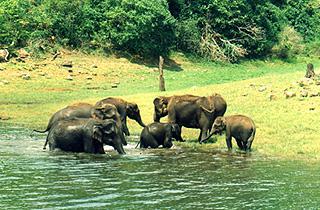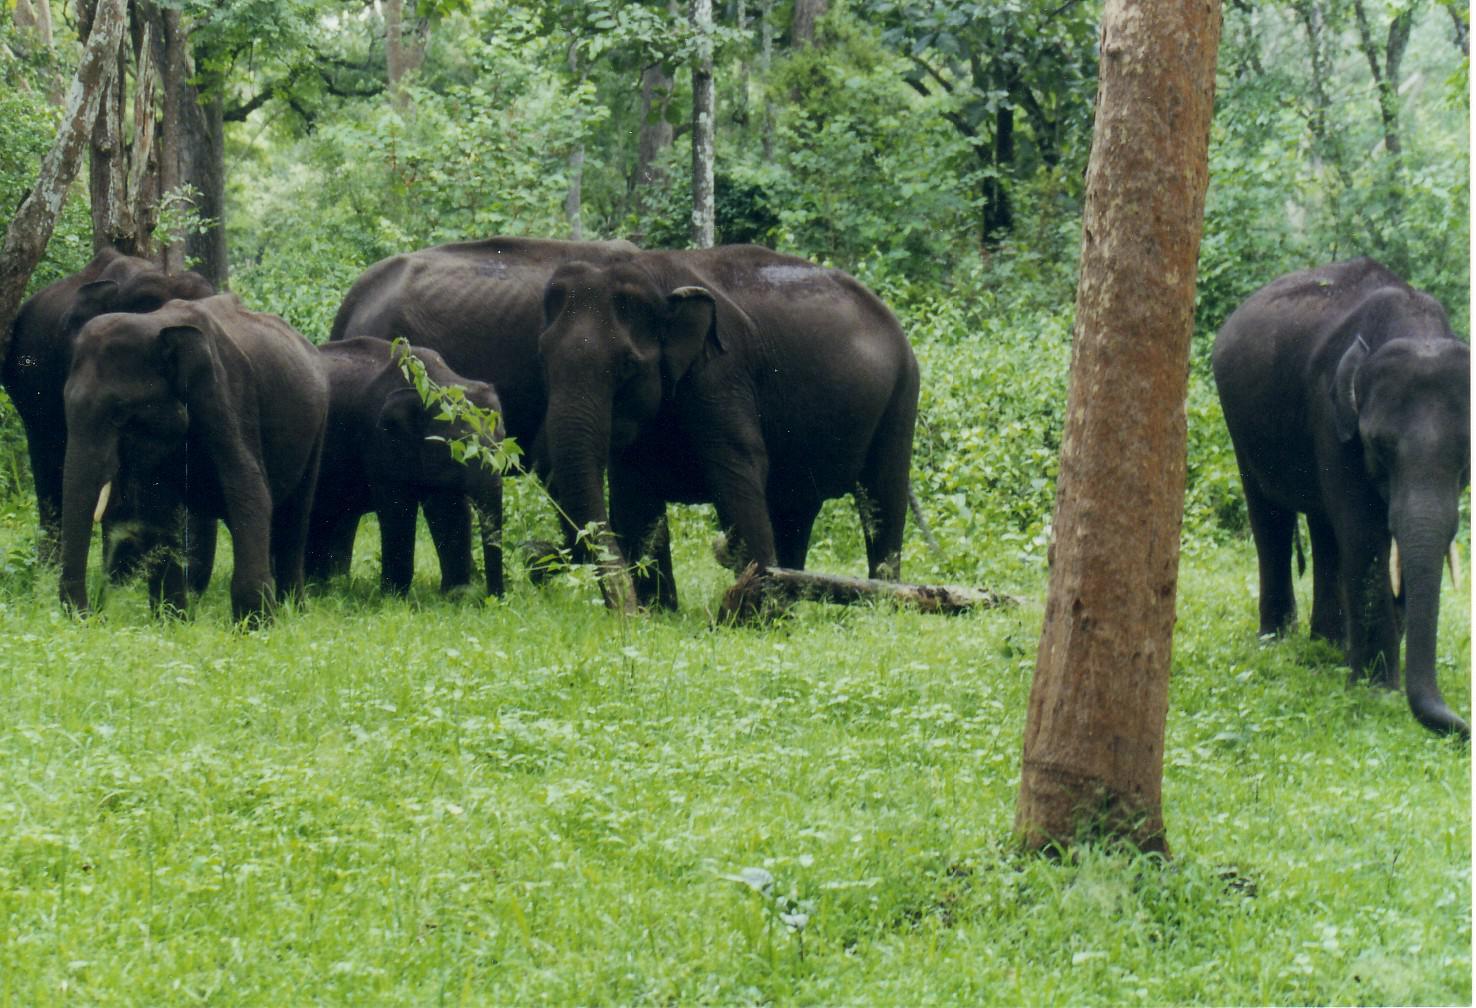The first image is the image on the left, the second image is the image on the right. Evaluate the accuracy of this statement regarding the images: "An image shows a group of elephants near a pool of water, but not in the water.". Is it true? Answer yes or no. No. The first image is the image on the left, the second image is the image on the right. For the images displayed, is the sentence "The animals in the image on the right are near watere." factually correct? Answer yes or no. No. 